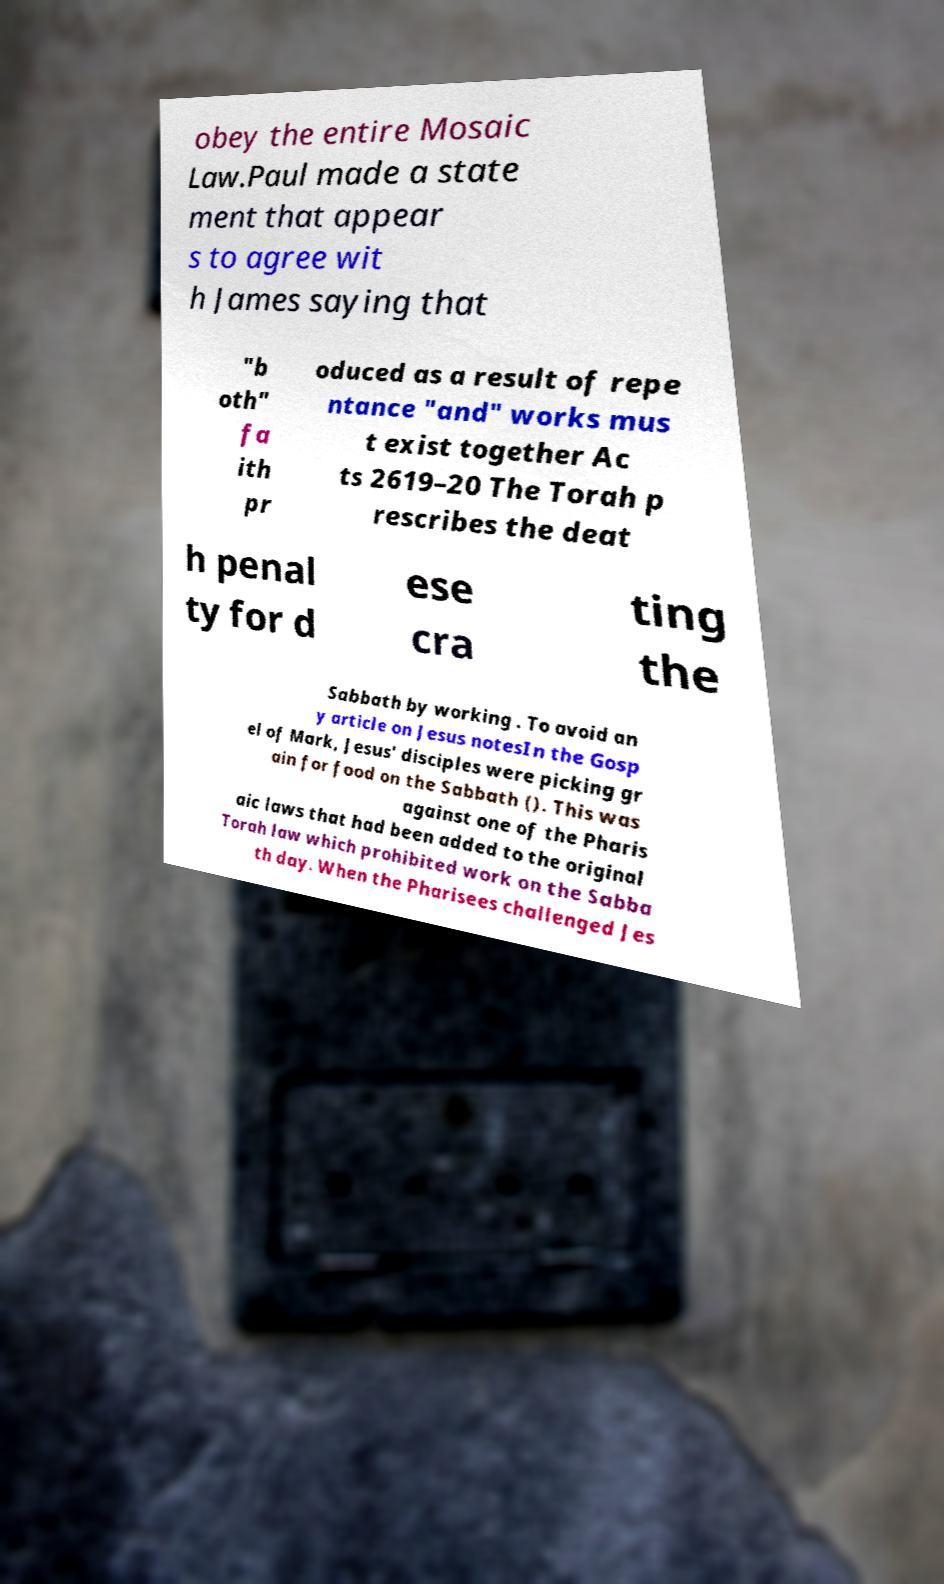Could you assist in decoding the text presented in this image and type it out clearly? obey the entire Mosaic Law.Paul made a state ment that appear s to agree wit h James saying that "b oth" fa ith pr oduced as a result of repe ntance "and" works mus t exist together Ac ts 2619–20 The Torah p rescribes the deat h penal ty for d ese cra ting the Sabbath by working . To avoid an y article on Jesus notesIn the Gosp el of Mark, Jesus' disciples were picking gr ain for food on the Sabbath (). This was against one of the Pharis aic laws that had been added to the original Torah law which prohibited work on the Sabba th day. When the Pharisees challenged Jes 